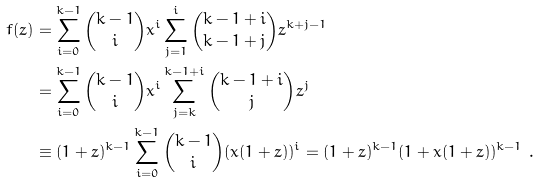Convert formula to latex. <formula><loc_0><loc_0><loc_500><loc_500>f ( z ) & = \sum _ { i = 0 } ^ { k - 1 } \binom { k - 1 } i x ^ { i } \sum _ { j = 1 } ^ { i } \binom { k - 1 + i } { k - 1 + j } z ^ { k + j - 1 } \\ & = \sum _ { i = 0 } ^ { k - 1 } \binom { k - 1 } i x ^ { i } \sum _ { j = k } ^ { k - 1 + i } \binom { k - 1 + i } j z ^ { j } \\ & \equiv ( 1 + z ) ^ { k - 1 } \sum _ { i = 0 } ^ { k - 1 } \binom { k - 1 } i ( x ( 1 + z ) ) ^ { i } = ( 1 + z ) ^ { k - 1 } ( 1 + x ( 1 + z ) ) ^ { k - 1 } \ .</formula> 